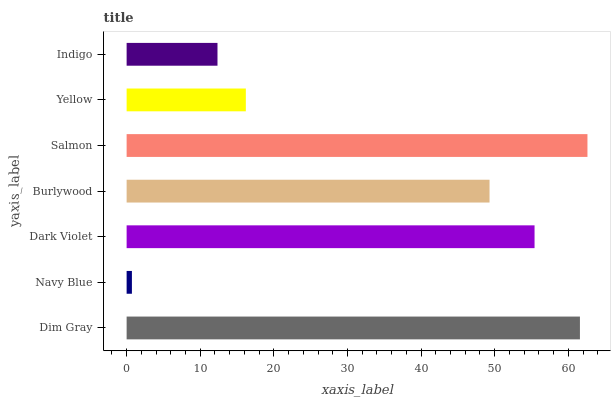Is Navy Blue the minimum?
Answer yes or no. Yes. Is Salmon the maximum?
Answer yes or no. Yes. Is Dark Violet the minimum?
Answer yes or no. No. Is Dark Violet the maximum?
Answer yes or no. No. Is Dark Violet greater than Navy Blue?
Answer yes or no. Yes. Is Navy Blue less than Dark Violet?
Answer yes or no. Yes. Is Navy Blue greater than Dark Violet?
Answer yes or no. No. Is Dark Violet less than Navy Blue?
Answer yes or no. No. Is Burlywood the high median?
Answer yes or no. Yes. Is Burlywood the low median?
Answer yes or no. Yes. Is Dim Gray the high median?
Answer yes or no. No. Is Salmon the low median?
Answer yes or no. No. 